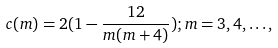Convert formula to latex. <formula><loc_0><loc_0><loc_500><loc_500>c ( m ) = 2 ( 1 - \frac { 1 2 } { m ( m + 4 ) } ) ; m = 3 , 4 , \dots ,</formula> 